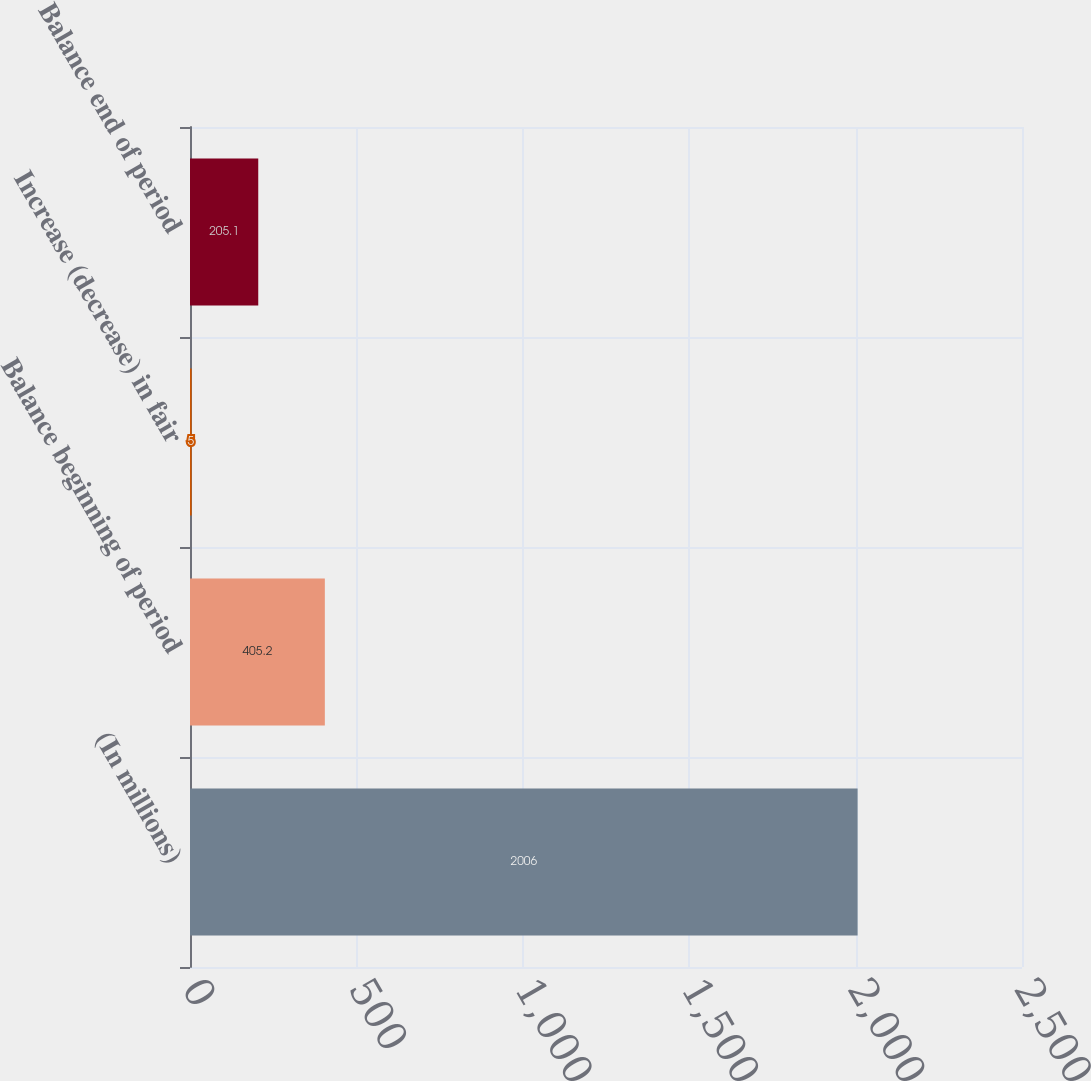<chart> <loc_0><loc_0><loc_500><loc_500><bar_chart><fcel>(In millions)<fcel>Balance beginning of period<fcel>Increase (decrease) in fair<fcel>Balance end of period<nl><fcel>2006<fcel>405.2<fcel>5<fcel>205.1<nl></chart> 